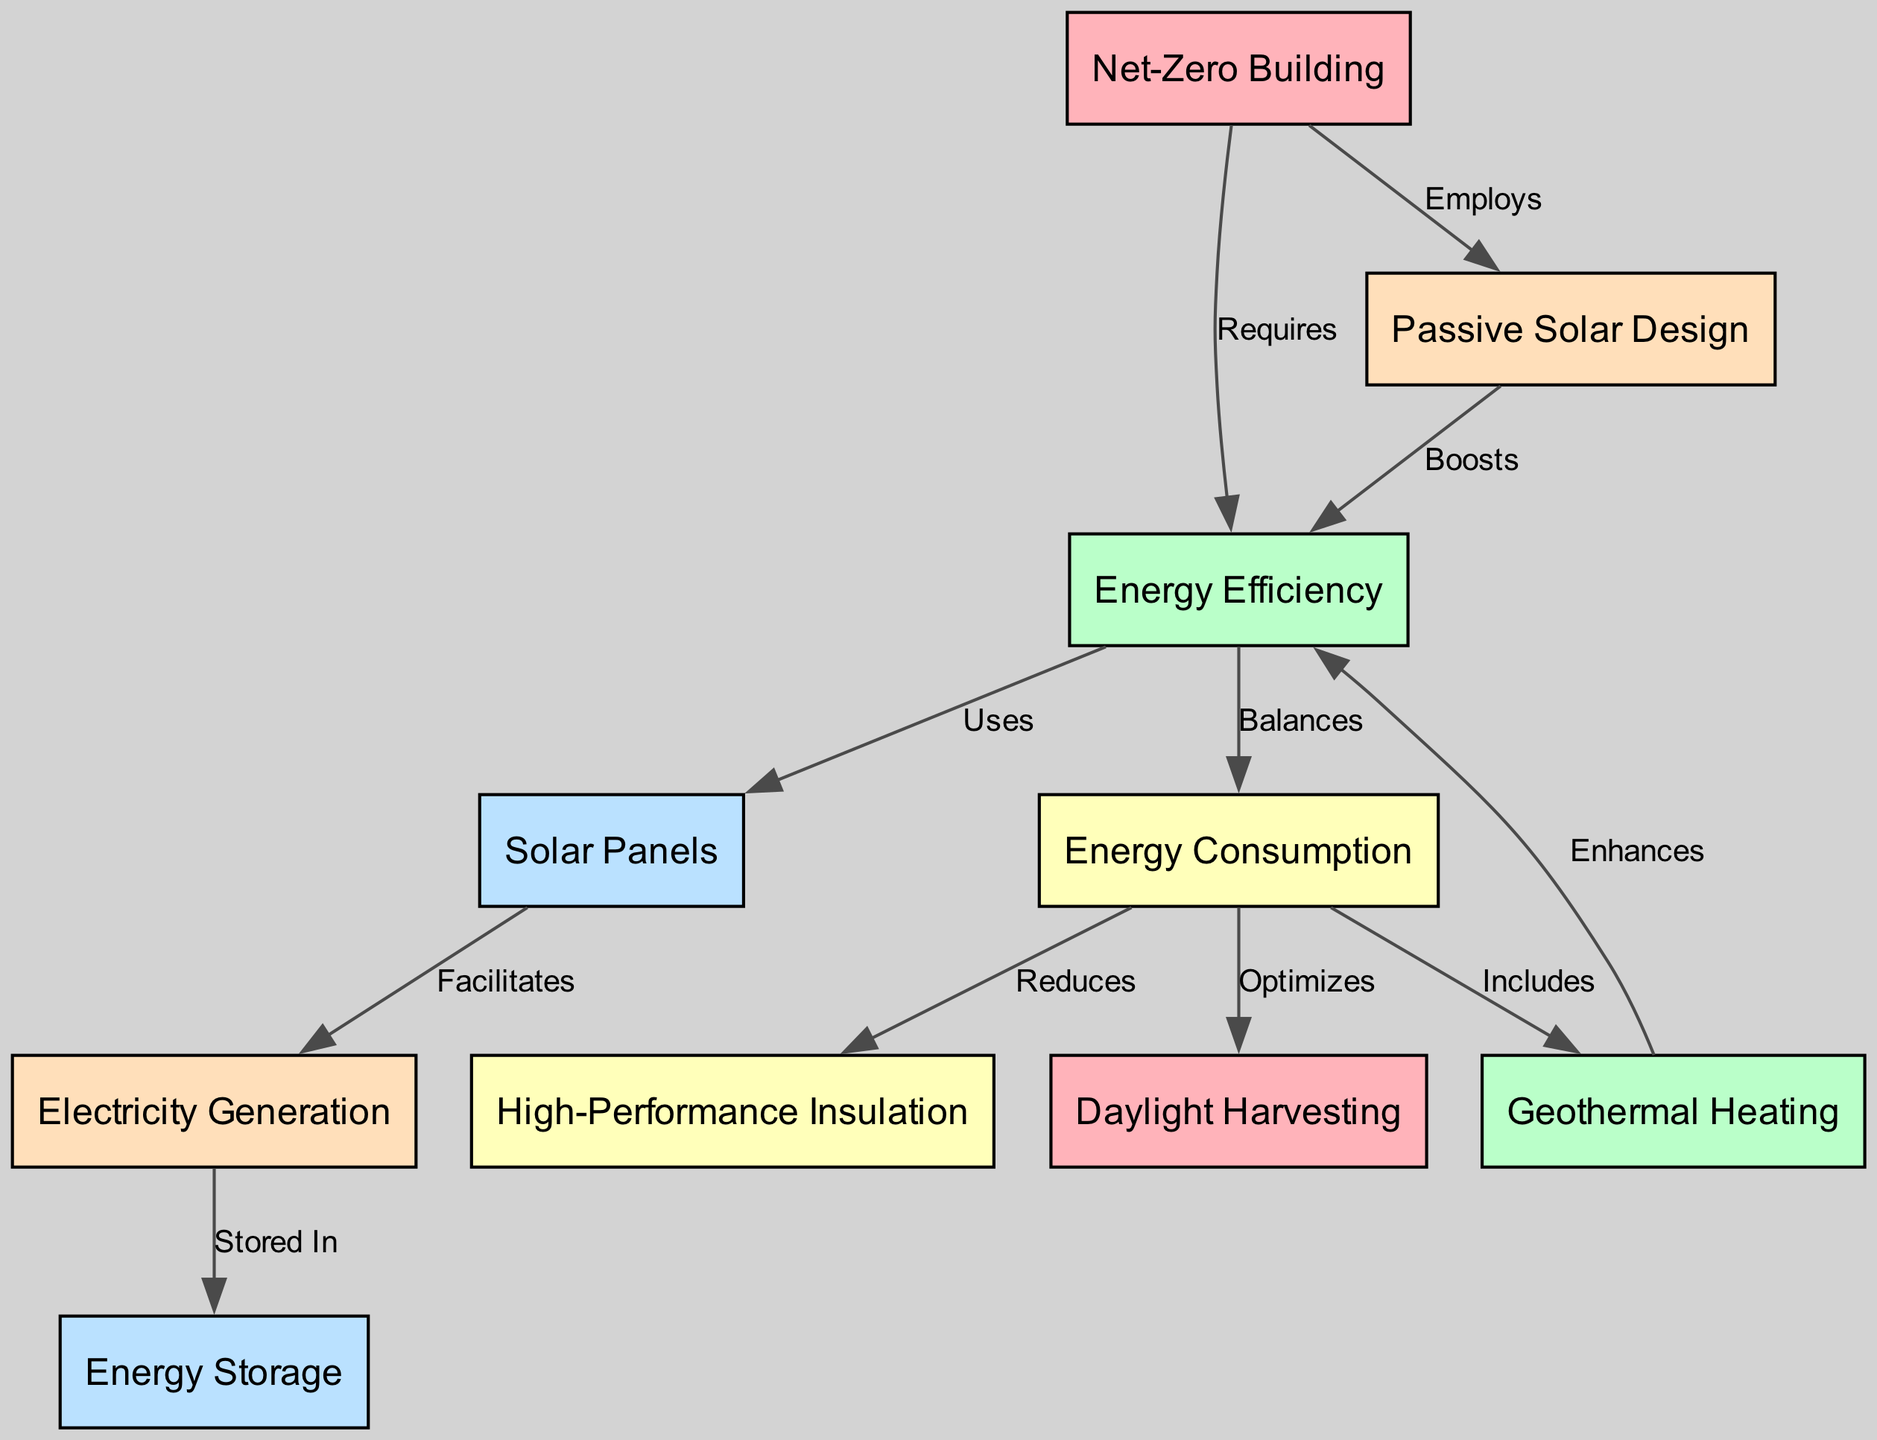What is the primary output generated from the solar panels? The diagram indicates that the solar panels facilitate electricity generation. They serve as the source which subsequently leads to energy storage.
Answer: Electricity Generation How many nodes are present in the diagram? Counting the nodes listed in the data, there are a total of ten nodes that represent various components of the energy efficiency system in the net-zero building.
Answer: Ten What relationship exists between energy efficiency and energy consumption? The diagram shows that energy efficiency balances energy consumption, indicating that efficiency and consumption are interconnected in their relationship.
Answer: Balances Which system optimizes the energy consumption? According to the diagram, daylight harvesting is the system that optimizes energy consumption by reducing the need for artificial lighting during daylight hours.
Answer: Daylight Harvesting How does geothermal heating affect energy efficiency? The diagram details that geothermal heating enhances energy efficiency, suggesting a positive impact of geothermal heating on overall efficiency in energy use.
Answer: Enhances Which design approach is employed in the net-zero building? The diagram states that passive systems are employed in the net-zero building, indicating a reliance on natural energy flows and conditions to enhance efficiency.
Answer: Passive Solar Design What does energy consumption reduce in the net-zero building? The diagram points out that energy consumption reduces high-performance insulation, demonstrating a direct link between consumption levels and insulation effectiveness.
Answer: High-Performance Insulation What is stored in energy storage from electricity generation? It is illustrated in the diagram that electricity generation is stored in energy storage. Once generated, the electricity must be stored for later use.
Answer: Energy Storage Which component contributes to the optimization of energy consumption? The information in the diagram indicates that daylight harvesting contributes to optimizing energy consumption, playing a crucial role in energy management.
Answer: Daylight Harvesting What does the net-zero building require for energy efficiency? The diagram denotes that the net-zero building requires energy efficiency, highlighting its foundational role in the application of sustainable architecture.
Answer: Energy Efficiency 